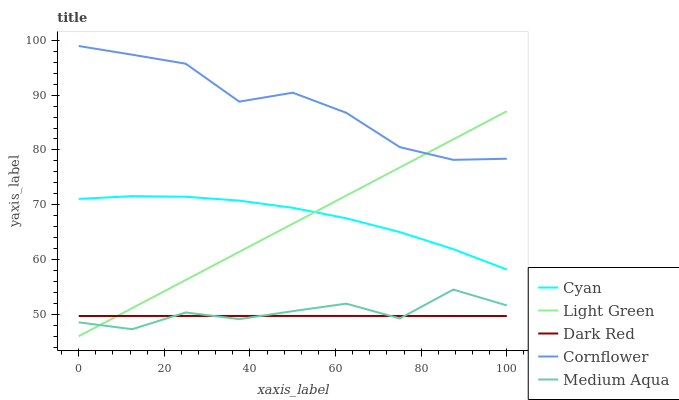Does Dark Red have the minimum area under the curve?
Answer yes or no. Yes. Does Cornflower have the maximum area under the curve?
Answer yes or no. Yes. Does Medium Aqua have the minimum area under the curve?
Answer yes or no. No. Does Medium Aqua have the maximum area under the curve?
Answer yes or no. No. Is Light Green the smoothest?
Answer yes or no. Yes. Is Medium Aqua the roughest?
Answer yes or no. Yes. Is Cornflower the smoothest?
Answer yes or no. No. Is Cornflower the roughest?
Answer yes or no. No. Does Light Green have the lowest value?
Answer yes or no. Yes. Does Medium Aqua have the lowest value?
Answer yes or no. No. Does Cornflower have the highest value?
Answer yes or no. Yes. Does Medium Aqua have the highest value?
Answer yes or no. No. Is Dark Red less than Cornflower?
Answer yes or no. Yes. Is Cyan greater than Dark Red?
Answer yes or no. Yes. Does Light Green intersect Cornflower?
Answer yes or no. Yes. Is Light Green less than Cornflower?
Answer yes or no. No. Is Light Green greater than Cornflower?
Answer yes or no. No. Does Dark Red intersect Cornflower?
Answer yes or no. No. 